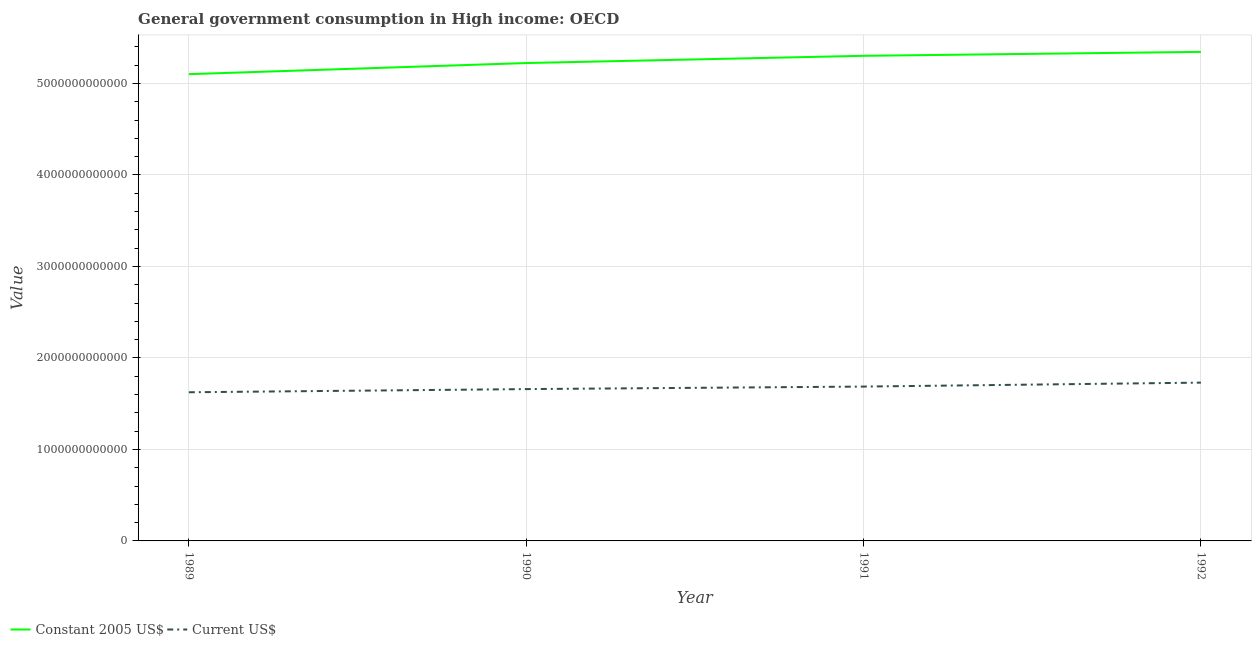How many different coloured lines are there?
Ensure brevity in your answer.  2. Does the line corresponding to value consumed in constant 2005 us$ intersect with the line corresponding to value consumed in current us$?
Keep it short and to the point. No. Is the number of lines equal to the number of legend labels?
Offer a terse response. Yes. What is the value consumed in current us$ in 1989?
Ensure brevity in your answer.  1.62e+12. Across all years, what is the maximum value consumed in constant 2005 us$?
Provide a succinct answer. 5.35e+12. Across all years, what is the minimum value consumed in constant 2005 us$?
Offer a very short reply. 5.10e+12. What is the total value consumed in constant 2005 us$ in the graph?
Give a very brief answer. 2.10e+13. What is the difference between the value consumed in constant 2005 us$ in 1990 and that in 1992?
Provide a short and direct response. -1.22e+11. What is the difference between the value consumed in constant 2005 us$ in 1991 and the value consumed in current us$ in 1989?
Provide a succinct answer. 3.68e+12. What is the average value consumed in current us$ per year?
Provide a succinct answer. 1.68e+12. In the year 1990, what is the difference between the value consumed in current us$ and value consumed in constant 2005 us$?
Keep it short and to the point. -3.56e+12. What is the ratio of the value consumed in constant 2005 us$ in 1989 to that in 1990?
Ensure brevity in your answer.  0.98. Is the value consumed in constant 2005 us$ in 1991 less than that in 1992?
Make the answer very short. Yes. Is the difference between the value consumed in current us$ in 1991 and 1992 greater than the difference between the value consumed in constant 2005 us$ in 1991 and 1992?
Your answer should be very brief. No. What is the difference between the highest and the second highest value consumed in current us$?
Your answer should be compact. 4.31e+1. What is the difference between the highest and the lowest value consumed in current us$?
Ensure brevity in your answer.  1.05e+11. Does the value consumed in constant 2005 us$ monotonically increase over the years?
Keep it short and to the point. Yes. How many lines are there?
Offer a terse response. 2. How many years are there in the graph?
Give a very brief answer. 4. What is the difference between two consecutive major ticks on the Y-axis?
Keep it short and to the point. 1.00e+12. What is the title of the graph?
Provide a succinct answer. General government consumption in High income: OECD. What is the label or title of the Y-axis?
Ensure brevity in your answer.  Value. What is the Value of Constant 2005 US$ in 1989?
Offer a very short reply. 5.10e+12. What is the Value in Current US$ in 1989?
Keep it short and to the point. 1.62e+12. What is the Value of Constant 2005 US$ in 1990?
Offer a very short reply. 5.22e+12. What is the Value of Current US$ in 1990?
Make the answer very short. 1.66e+12. What is the Value of Constant 2005 US$ in 1991?
Keep it short and to the point. 5.30e+12. What is the Value in Current US$ in 1991?
Your answer should be compact. 1.69e+12. What is the Value of Constant 2005 US$ in 1992?
Ensure brevity in your answer.  5.35e+12. What is the Value of Current US$ in 1992?
Make the answer very short. 1.73e+12. Across all years, what is the maximum Value of Constant 2005 US$?
Your response must be concise. 5.35e+12. Across all years, what is the maximum Value of Current US$?
Give a very brief answer. 1.73e+12. Across all years, what is the minimum Value in Constant 2005 US$?
Provide a short and direct response. 5.10e+12. Across all years, what is the minimum Value of Current US$?
Ensure brevity in your answer.  1.62e+12. What is the total Value of Constant 2005 US$ in the graph?
Your response must be concise. 2.10e+13. What is the total Value in Current US$ in the graph?
Your answer should be compact. 6.70e+12. What is the difference between the Value of Constant 2005 US$ in 1989 and that in 1990?
Your answer should be compact. -1.22e+11. What is the difference between the Value in Current US$ in 1989 and that in 1990?
Your answer should be very brief. -3.46e+1. What is the difference between the Value of Constant 2005 US$ in 1989 and that in 1991?
Your response must be concise. -2.01e+11. What is the difference between the Value of Current US$ in 1989 and that in 1991?
Your answer should be very brief. -6.22e+1. What is the difference between the Value in Constant 2005 US$ in 1989 and that in 1992?
Offer a very short reply. -2.43e+11. What is the difference between the Value of Current US$ in 1989 and that in 1992?
Provide a short and direct response. -1.05e+11. What is the difference between the Value in Constant 2005 US$ in 1990 and that in 1991?
Ensure brevity in your answer.  -7.91e+1. What is the difference between the Value in Current US$ in 1990 and that in 1991?
Your answer should be very brief. -2.76e+1. What is the difference between the Value of Constant 2005 US$ in 1990 and that in 1992?
Provide a short and direct response. -1.22e+11. What is the difference between the Value in Current US$ in 1990 and that in 1992?
Offer a terse response. -7.07e+1. What is the difference between the Value of Constant 2005 US$ in 1991 and that in 1992?
Provide a succinct answer. -4.28e+1. What is the difference between the Value of Current US$ in 1991 and that in 1992?
Offer a very short reply. -4.31e+1. What is the difference between the Value in Constant 2005 US$ in 1989 and the Value in Current US$ in 1990?
Your response must be concise. 3.44e+12. What is the difference between the Value of Constant 2005 US$ in 1989 and the Value of Current US$ in 1991?
Offer a very short reply. 3.41e+12. What is the difference between the Value in Constant 2005 US$ in 1989 and the Value in Current US$ in 1992?
Provide a succinct answer. 3.37e+12. What is the difference between the Value of Constant 2005 US$ in 1990 and the Value of Current US$ in 1991?
Your answer should be compact. 3.54e+12. What is the difference between the Value in Constant 2005 US$ in 1990 and the Value in Current US$ in 1992?
Offer a very short reply. 3.49e+12. What is the difference between the Value of Constant 2005 US$ in 1991 and the Value of Current US$ in 1992?
Keep it short and to the point. 3.57e+12. What is the average Value in Constant 2005 US$ per year?
Make the answer very short. 5.24e+12. What is the average Value in Current US$ per year?
Provide a short and direct response. 1.68e+12. In the year 1989, what is the difference between the Value in Constant 2005 US$ and Value in Current US$?
Your answer should be compact. 3.48e+12. In the year 1990, what is the difference between the Value in Constant 2005 US$ and Value in Current US$?
Provide a short and direct response. 3.56e+12. In the year 1991, what is the difference between the Value in Constant 2005 US$ and Value in Current US$?
Provide a short and direct response. 3.62e+12. In the year 1992, what is the difference between the Value in Constant 2005 US$ and Value in Current US$?
Keep it short and to the point. 3.62e+12. What is the ratio of the Value in Constant 2005 US$ in 1989 to that in 1990?
Give a very brief answer. 0.98. What is the ratio of the Value in Current US$ in 1989 to that in 1990?
Give a very brief answer. 0.98. What is the ratio of the Value in Constant 2005 US$ in 1989 to that in 1991?
Your response must be concise. 0.96. What is the ratio of the Value in Current US$ in 1989 to that in 1991?
Your response must be concise. 0.96. What is the ratio of the Value of Constant 2005 US$ in 1989 to that in 1992?
Keep it short and to the point. 0.95. What is the ratio of the Value in Current US$ in 1989 to that in 1992?
Provide a succinct answer. 0.94. What is the ratio of the Value of Constant 2005 US$ in 1990 to that in 1991?
Ensure brevity in your answer.  0.99. What is the ratio of the Value of Current US$ in 1990 to that in 1991?
Your response must be concise. 0.98. What is the ratio of the Value in Constant 2005 US$ in 1990 to that in 1992?
Ensure brevity in your answer.  0.98. What is the ratio of the Value of Current US$ in 1990 to that in 1992?
Provide a short and direct response. 0.96. What is the ratio of the Value in Constant 2005 US$ in 1991 to that in 1992?
Offer a terse response. 0.99. What is the ratio of the Value in Current US$ in 1991 to that in 1992?
Give a very brief answer. 0.98. What is the difference between the highest and the second highest Value in Constant 2005 US$?
Ensure brevity in your answer.  4.28e+1. What is the difference between the highest and the second highest Value in Current US$?
Your answer should be compact. 4.31e+1. What is the difference between the highest and the lowest Value in Constant 2005 US$?
Your answer should be very brief. 2.43e+11. What is the difference between the highest and the lowest Value in Current US$?
Your answer should be very brief. 1.05e+11. 